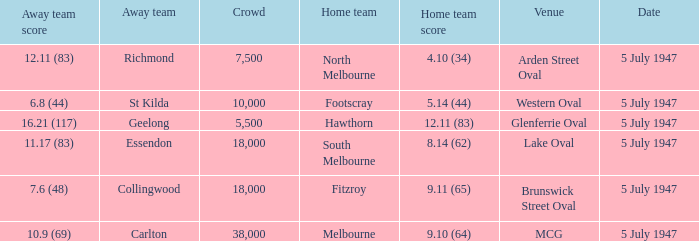What home team played an away team with a score of 6.8 (44)? Footscray. 